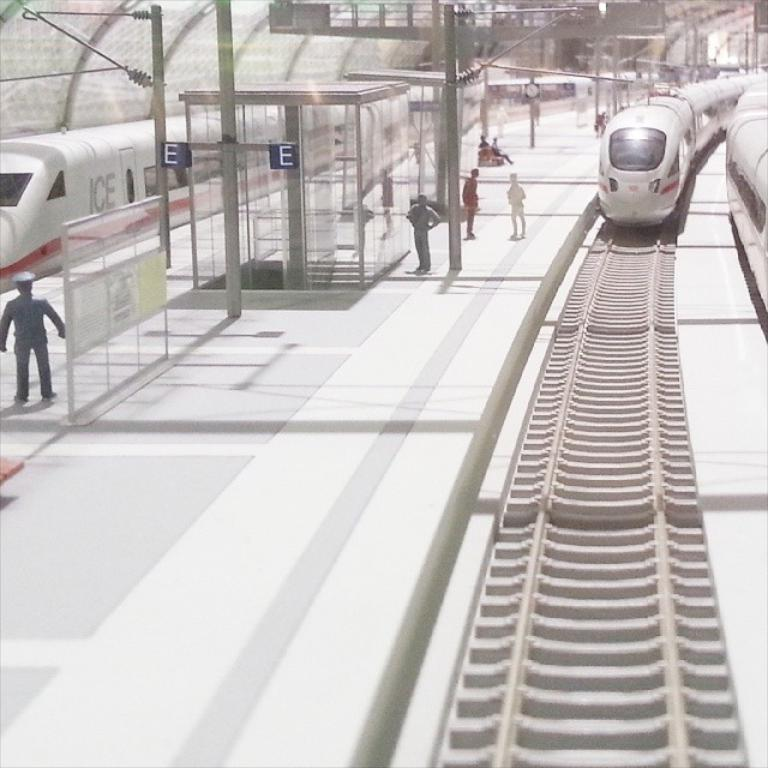<image>
Describe the image concisely. train coming into the "E" stop as several people wait there 